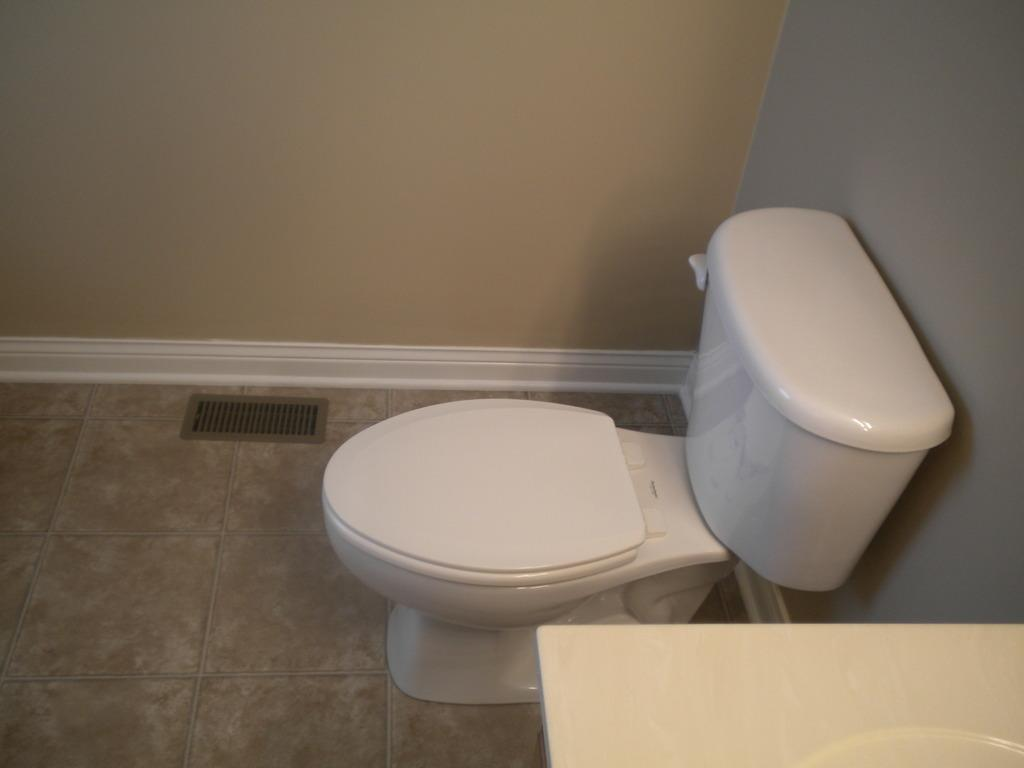What is the main object in the foreground of the image? There is an object in the foreground of the image, but the specific details are not provided. What can be found in the middle of the image? There is a toilet tank and a toilet seat in the middle of the image. What part of the bathroom is visible in the image? The floor is visible in the image. What type of material is present in the image? There is a mesh in the image. What is the background of the image? There is a wall in the image. What type of error can be seen on the airport's temper in the image? There is no airport or temper present in the image. The image features a toilet tank, toilet seat, and other bathroom-related objects. 